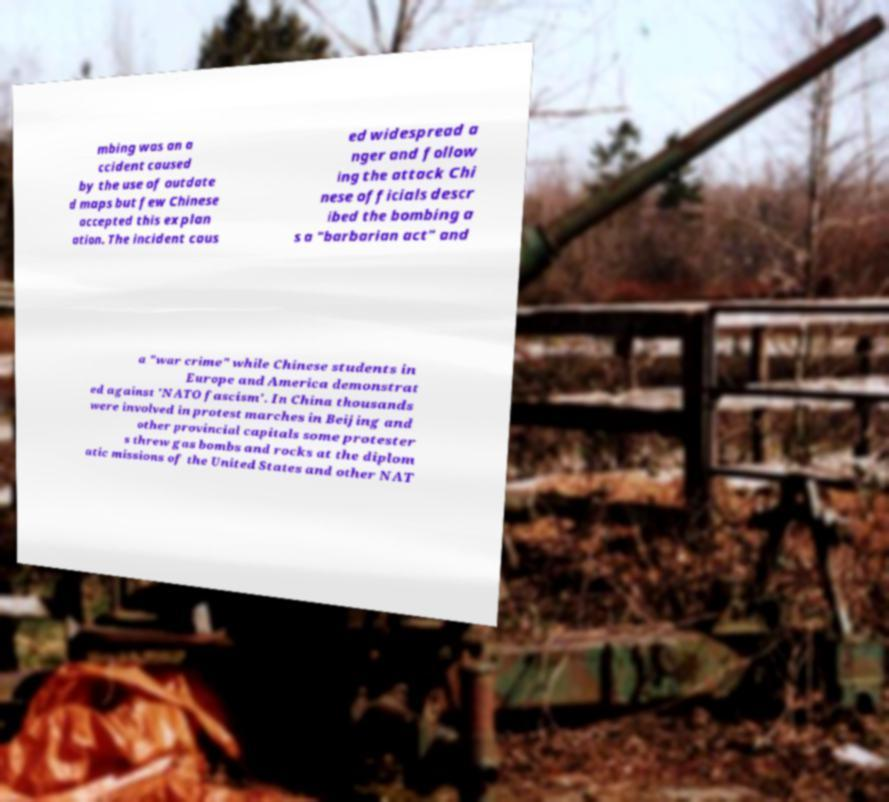Can you accurately transcribe the text from the provided image for me? mbing was an a ccident caused by the use of outdate d maps but few Chinese accepted this explan ation. The incident caus ed widespread a nger and follow ing the attack Chi nese officials descr ibed the bombing a s a "barbarian act" and a "war crime" while Chinese students in Europe and America demonstrat ed against 'NATO fascism'. In China thousands were involved in protest marches in Beijing and other provincial capitals some protester s threw gas bombs and rocks at the diplom atic missions of the United States and other NAT 